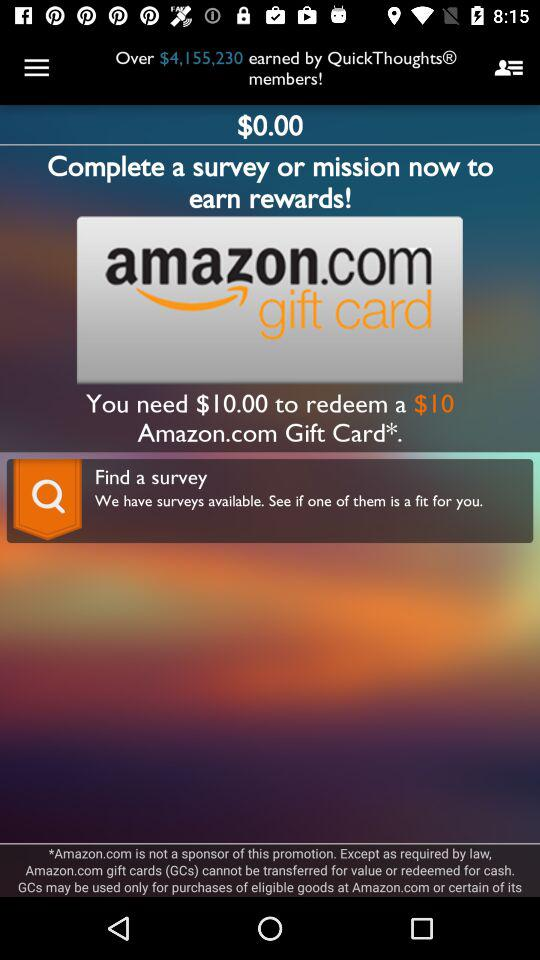How many surveys can be found?
When the provided information is insufficient, respond with <no answer>. <no answer> 